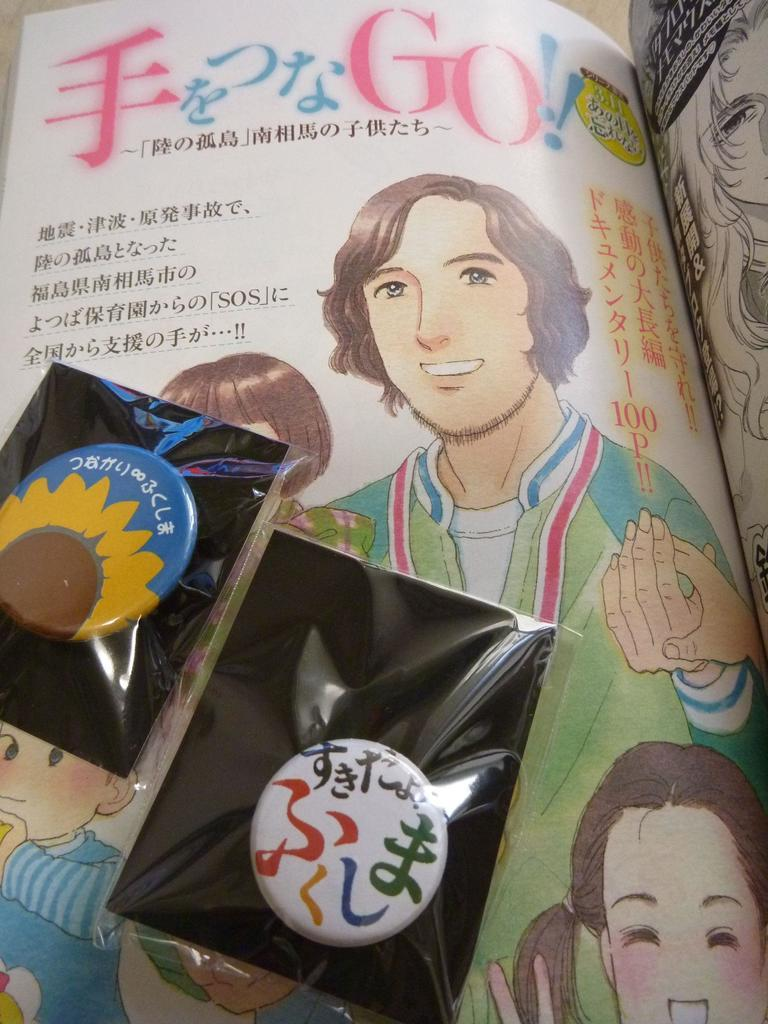What object can be seen in the image related to reading or learning? There is a book in the image. What can be found on the book's pages? The book has images on it. Is there any written content on the book? Yes, there is text written on the book. What additional item is found inside the book's cover? There is a badge inside the cover of the book. Can you see any tin cans floating down the river with babies inside in the image? There is no river or tin cans with babies present in the image; it only features a book with images, text, and a badge inside the cover. 